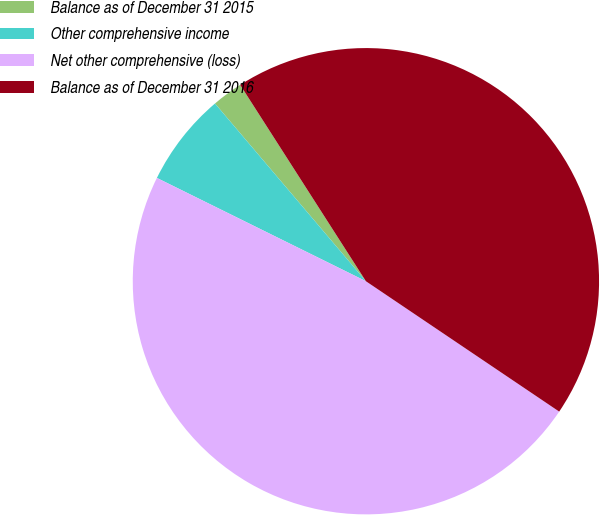Convert chart. <chart><loc_0><loc_0><loc_500><loc_500><pie_chart><fcel>Balance as of December 31 2015<fcel>Other comprehensive income<fcel>Net other comprehensive (loss)<fcel>Balance as of December 31 2016<nl><fcel>2.14%<fcel>6.49%<fcel>47.86%<fcel>43.51%<nl></chart> 